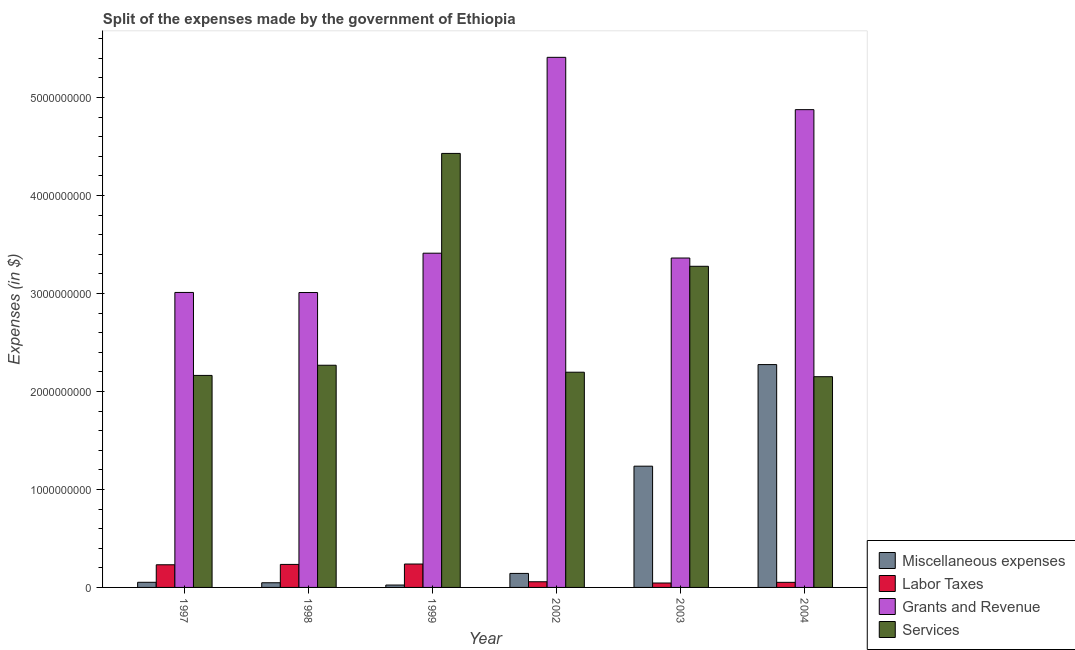How many different coloured bars are there?
Make the answer very short. 4. What is the amount spent on grants and revenue in 1999?
Provide a succinct answer. 3.41e+09. Across all years, what is the maximum amount spent on labor taxes?
Provide a succinct answer. 2.39e+08. Across all years, what is the minimum amount spent on labor taxes?
Keep it short and to the point. 4.51e+07. In which year was the amount spent on labor taxes maximum?
Ensure brevity in your answer.  1999. In which year was the amount spent on miscellaneous expenses minimum?
Offer a terse response. 1999. What is the total amount spent on miscellaneous expenses in the graph?
Ensure brevity in your answer.  3.78e+09. What is the difference between the amount spent on miscellaneous expenses in 1998 and that in 1999?
Make the answer very short. 2.33e+07. What is the difference between the amount spent on grants and revenue in 1997 and the amount spent on miscellaneous expenses in 1998?
Keep it short and to the point. 8.00e+05. What is the average amount spent on services per year?
Provide a short and direct response. 2.75e+09. In how many years, is the amount spent on labor taxes greater than 5200000000 $?
Your answer should be very brief. 0. What is the ratio of the amount spent on labor taxes in 2003 to that in 2004?
Provide a short and direct response. 0.87. Is the difference between the amount spent on grants and revenue in 2002 and 2003 greater than the difference between the amount spent on services in 2002 and 2003?
Your answer should be compact. No. What is the difference between the highest and the second highest amount spent on services?
Ensure brevity in your answer.  1.15e+09. What is the difference between the highest and the lowest amount spent on labor taxes?
Give a very brief answer. 1.94e+08. In how many years, is the amount spent on grants and revenue greater than the average amount spent on grants and revenue taken over all years?
Offer a very short reply. 2. Is it the case that in every year, the sum of the amount spent on miscellaneous expenses and amount spent on labor taxes is greater than the sum of amount spent on grants and revenue and amount spent on services?
Your response must be concise. No. What does the 1st bar from the left in 1998 represents?
Your response must be concise. Miscellaneous expenses. What does the 4th bar from the right in 2002 represents?
Offer a terse response. Miscellaneous expenses. Are all the bars in the graph horizontal?
Your response must be concise. No. How many years are there in the graph?
Provide a short and direct response. 6. Where does the legend appear in the graph?
Your answer should be very brief. Bottom right. How many legend labels are there?
Your answer should be compact. 4. How are the legend labels stacked?
Your response must be concise. Vertical. What is the title of the graph?
Offer a very short reply. Split of the expenses made by the government of Ethiopia. Does "Social equity" appear as one of the legend labels in the graph?
Offer a very short reply. No. What is the label or title of the Y-axis?
Provide a succinct answer. Expenses (in $). What is the Expenses (in $) in Miscellaneous expenses in 1997?
Offer a very short reply. 5.25e+07. What is the Expenses (in $) in Labor Taxes in 1997?
Provide a succinct answer. 2.31e+08. What is the Expenses (in $) in Grants and Revenue in 1997?
Ensure brevity in your answer.  3.01e+09. What is the Expenses (in $) in Services in 1997?
Provide a short and direct response. 2.16e+09. What is the Expenses (in $) in Miscellaneous expenses in 1998?
Your answer should be compact. 4.77e+07. What is the Expenses (in $) in Labor Taxes in 1998?
Your answer should be very brief. 2.35e+08. What is the Expenses (in $) of Grants and Revenue in 1998?
Offer a very short reply. 3.01e+09. What is the Expenses (in $) in Services in 1998?
Your answer should be very brief. 2.27e+09. What is the Expenses (in $) of Miscellaneous expenses in 1999?
Give a very brief answer. 2.44e+07. What is the Expenses (in $) in Labor Taxes in 1999?
Provide a succinct answer. 2.39e+08. What is the Expenses (in $) of Grants and Revenue in 1999?
Provide a short and direct response. 3.41e+09. What is the Expenses (in $) of Services in 1999?
Your answer should be compact. 4.43e+09. What is the Expenses (in $) in Miscellaneous expenses in 2002?
Offer a terse response. 1.43e+08. What is the Expenses (in $) of Labor Taxes in 2002?
Your response must be concise. 5.79e+07. What is the Expenses (in $) of Grants and Revenue in 2002?
Your answer should be very brief. 5.41e+09. What is the Expenses (in $) of Services in 2002?
Provide a short and direct response. 2.20e+09. What is the Expenses (in $) of Miscellaneous expenses in 2003?
Offer a very short reply. 1.24e+09. What is the Expenses (in $) of Labor Taxes in 2003?
Offer a very short reply. 4.51e+07. What is the Expenses (in $) of Grants and Revenue in 2003?
Keep it short and to the point. 3.36e+09. What is the Expenses (in $) in Services in 2003?
Provide a short and direct response. 3.28e+09. What is the Expenses (in $) in Miscellaneous expenses in 2004?
Offer a terse response. 2.27e+09. What is the Expenses (in $) of Labor Taxes in 2004?
Your response must be concise. 5.20e+07. What is the Expenses (in $) in Grants and Revenue in 2004?
Provide a succinct answer. 4.88e+09. What is the Expenses (in $) of Services in 2004?
Your answer should be compact. 2.15e+09. Across all years, what is the maximum Expenses (in $) of Miscellaneous expenses?
Your answer should be compact. 2.27e+09. Across all years, what is the maximum Expenses (in $) of Labor Taxes?
Ensure brevity in your answer.  2.39e+08. Across all years, what is the maximum Expenses (in $) in Grants and Revenue?
Your answer should be very brief. 5.41e+09. Across all years, what is the maximum Expenses (in $) of Services?
Ensure brevity in your answer.  4.43e+09. Across all years, what is the minimum Expenses (in $) of Miscellaneous expenses?
Provide a succinct answer. 2.44e+07. Across all years, what is the minimum Expenses (in $) of Labor Taxes?
Your response must be concise. 4.51e+07. Across all years, what is the minimum Expenses (in $) in Grants and Revenue?
Provide a succinct answer. 3.01e+09. Across all years, what is the minimum Expenses (in $) of Services?
Give a very brief answer. 2.15e+09. What is the total Expenses (in $) of Miscellaneous expenses in the graph?
Your answer should be very brief. 3.78e+09. What is the total Expenses (in $) of Labor Taxes in the graph?
Your answer should be very brief. 8.60e+08. What is the total Expenses (in $) of Grants and Revenue in the graph?
Make the answer very short. 2.31e+1. What is the total Expenses (in $) in Services in the graph?
Give a very brief answer. 1.65e+1. What is the difference between the Expenses (in $) of Miscellaneous expenses in 1997 and that in 1998?
Offer a terse response. 4.80e+06. What is the difference between the Expenses (in $) of Labor Taxes in 1997 and that in 1998?
Provide a succinct answer. -3.60e+06. What is the difference between the Expenses (in $) in Services in 1997 and that in 1998?
Provide a succinct answer. -1.04e+08. What is the difference between the Expenses (in $) in Miscellaneous expenses in 1997 and that in 1999?
Make the answer very short. 2.81e+07. What is the difference between the Expenses (in $) of Labor Taxes in 1997 and that in 1999?
Provide a short and direct response. -7.60e+06. What is the difference between the Expenses (in $) in Grants and Revenue in 1997 and that in 1999?
Your answer should be compact. -4.01e+08. What is the difference between the Expenses (in $) of Services in 1997 and that in 1999?
Your answer should be very brief. -2.27e+09. What is the difference between the Expenses (in $) of Miscellaneous expenses in 1997 and that in 2002?
Provide a succinct answer. -9.05e+07. What is the difference between the Expenses (in $) of Labor Taxes in 1997 and that in 2002?
Provide a short and direct response. 1.73e+08. What is the difference between the Expenses (in $) of Grants and Revenue in 1997 and that in 2002?
Provide a succinct answer. -2.40e+09. What is the difference between the Expenses (in $) of Services in 1997 and that in 2002?
Your answer should be compact. -3.27e+07. What is the difference between the Expenses (in $) in Miscellaneous expenses in 1997 and that in 2003?
Your response must be concise. -1.18e+09. What is the difference between the Expenses (in $) of Labor Taxes in 1997 and that in 2003?
Give a very brief answer. 1.86e+08. What is the difference between the Expenses (in $) in Grants and Revenue in 1997 and that in 2003?
Offer a very short reply. -3.51e+08. What is the difference between the Expenses (in $) in Services in 1997 and that in 2003?
Keep it short and to the point. -1.11e+09. What is the difference between the Expenses (in $) in Miscellaneous expenses in 1997 and that in 2004?
Ensure brevity in your answer.  -2.22e+09. What is the difference between the Expenses (in $) of Labor Taxes in 1997 and that in 2004?
Offer a very short reply. 1.79e+08. What is the difference between the Expenses (in $) in Grants and Revenue in 1997 and that in 2004?
Provide a short and direct response. -1.87e+09. What is the difference between the Expenses (in $) in Services in 1997 and that in 2004?
Provide a succinct answer. 1.30e+07. What is the difference between the Expenses (in $) in Miscellaneous expenses in 1998 and that in 1999?
Offer a very short reply. 2.33e+07. What is the difference between the Expenses (in $) in Labor Taxes in 1998 and that in 1999?
Your response must be concise. -4.00e+06. What is the difference between the Expenses (in $) of Grants and Revenue in 1998 and that in 1999?
Give a very brief answer. -4.01e+08. What is the difference between the Expenses (in $) in Services in 1998 and that in 1999?
Provide a succinct answer. -2.16e+09. What is the difference between the Expenses (in $) in Miscellaneous expenses in 1998 and that in 2002?
Offer a terse response. -9.53e+07. What is the difference between the Expenses (in $) in Labor Taxes in 1998 and that in 2002?
Your answer should be very brief. 1.77e+08. What is the difference between the Expenses (in $) of Grants and Revenue in 1998 and that in 2002?
Offer a very short reply. -2.40e+09. What is the difference between the Expenses (in $) of Services in 1998 and that in 2002?
Offer a very short reply. 7.11e+07. What is the difference between the Expenses (in $) of Miscellaneous expenses in 1998 and that in 2003?
Give a very brief answer. -1.19e+09. What is the difference between the Expenses (in $) in Labor Taxes in 1998 and that in 2003?
Ensure brevity in your answer.  1.90e+08. What is the difference between the Expenses (in $) in Grants and Revenue in 1998 and that in 2003?
Make the answer very short. -3.52e+08. What is the difference between the Expenses (in $) of Services in 1998 and that in 2003?
Ensure brevity in your answer.  -1.01e+09. What is the difference between the Expenses (in $) in Miscellaneous expenses in 1998 and that in 2004?
Offer a very short reply. -2.23e+09. What is the difference between the Expenses (in $) in Labor Taxes in 1998 and that in 2004?
Provide a succinct answer. 1.83e+08. What is the difference between the Expenses (in $) in Grants and Revenue in 1998 and that in 2004?
Give a very brief answer. -1.87e+09. What is the difference between the Expenses (in $) of Services in 1998 and that in 2004?
Keep it short and to the point. 1.17e+08. What is the difference between the Expenses (in $) in Miscellaneous expenses in 1999 and that in 2002?
Your answer should be compact. -1.19e+08. What is the difference between the Expenses (in $) of Labor Taxes in 1999 and that in 2002?
Make the answer very short. 1.81e+08. What is the difference between the Expenses (in $) of Grants and Revenue in 1999 and that in 2002?
Your answer should be very brief. -2.00e+09. What is the difference between the Expenses (in $) in Services in 1999 and that in 2002?
Your answer should be very brief. 2.23e+09. What is the difference between the Expenses (in $) in Miscellaneous expenses in 1999 and that in 2003?
Keep it short and to the point. -1.21e+09. What is the difference between the Expenses (in $) in Labor Taxes in 1999 and that in 2003?
Keep it short and to the point. 1.94e+08. What is the difference between the Expenses (in $) in Grants and Revenue in 1999 and that in 2003?
Your response must be concise. 4.93e+07. What is the difference between the Expenses (in $) in Services in 1999 and that in 2003?
Make the answer very short. 1.15e+09. What is the difference between the Expenses (in $) in Miscellaneous expenses in 1999 and that in 2004?
Provide a short and direct response. -2.25e+09. What is the difference between the Expenses (in $) of Labor Taxes in 1999 and that in 2004?
Your answer should be compact. 1.87e+08. What is the difference between the Expenses (in $) in Grants and Revenue in 1999 and that in 2004?
Your answer should be compact. -1.46e+09. What is the difference between the Expenses (in $) in Services in 1999 and that in 2004?
Make the answer very short. 2.28e+09. What is the difference between the Expenses (in $) of Miscellaneous expenses in 2002 and that in 2003?
Your response must be concise. -1.09e+09. What is the difference between the Expenses (in $) in Labor Taxes in 2002 and that in 2003?
Give a very brief answer. 1.28e+07. What is the difference between the Expenses (in $) of Grants and Revenue in 2002 and that in 2003?
Offer a terse response. 2.05e+09. What is the difference between the Expenses (in $) in Services in 2002 and that in 2003?
Give a very brief answer. -1.08e+09. What is the difference between the Expenses (in $) of Miscellaneous expenses in 2002 and that in 2004?
Your response must be concise. -2.13e+09. What is the difference between the Expenses (in $) in Labor Taxes in 2002 and that in 2004?
Provide a short and direct response. 5.90e+06. What is the difference between the Expenses (in $) of Grants and Revenue in 2002 and that in 2004?
Your response must be concise. 5.34e+08. What is the difference between the Expenses (in $) in Services in 2002 and that in 2004?
Provide a short and direct response. 4.57e+07. What is the difference between the Expenses (in $) of Miscellaneous expenses in 2003 and that in 2004?
Offer a very short reply. -1.04e+09. What is the difference between the Expenses (in $) in Labor Taxes in 2003 and that in 2004?
Your answer should be very brief. -6.90e+06. What is the difference between the Expenses (in $) in Grants and Revenue in 2003 and that in 2004?
Your answer should be very brief. -1.51e+09. What is the difference between the Expenses (in $) of Services in 2003 and that in 2004?
Ensure brevity in your answer.  1.13e+09. What is the difference between the Expenses (in $) of Miscellaneous expenses in 1997 and the Expenses (in $) of Labor Taxes in 1998?
Ensure brevity in your answer.  -1.82e+08. What is the difference between the Expenses (in $) in Miscellaneous expenses in 1997 and the Expenses (in $) in Grants and Revenue in 1998?
Provide a short and direct response. -2.96e+09. What is the difference between the Expenses (in $) of Miscellaneous expenses in 1997 and the Expenses (in $) of Services in 1998?
Ensure brevity in your answer.  -2.22e+09. What is the difference between the Expenses (in $) in Labor Taxes in 1997 and the Expenses (in $) in Grants and Revenue in 1998?
Provide a succinct answer. -2.78e+09. What is the difference between the Expenses (in $) in Labor Taxes in 1997 and the Expenses (in $) in Services in 1998?
Keep it short and to the point. -2.04e+09. What is the difference between the Expenses (in $) of Grants and Revenue in 1997 and the Expenses (in $) of Services in 1998?
Your answer should be compact. 7.43e+08. What is the difference between the Expenses (in $) of Miscellaneous expenses in 1997 and the Expenses (in $) of Labor Taxes in 1999?
Your answer should be very brief. -1.86e+08. What is the difference between the Expenses (in $) of Miscellaneous expenses in 1997 and the Expenses (in $) of Grants and Revenue in 1999?
Offer a very short reply. -3.36e+09. What is the difference between the Expenses (in $) in Miscellaneous expenses in 1997 and the Expenses (in $) in Services in 1999?
Your answer should be compact. -4.38e+09. What is the difference between the Expenses (in $) of Labor Taxes in 1997 and the Expenses (in $) of Grants and Revenue in 1999?
Give a very brief answer. -3.18e+09. What is the difference between the Expenses (in $) in Labor Taxes in 1997 and the Expenses (in $) in Services in 1999?
Give a very brief answer. -4.20e+09. What is the difference between the Expenses (in $) in Grants and Revenue in 1997 and the Expenses (in $) in Services in 1999?
Your response must be concise. -1.42e+09. What is the difference between the Expenses (in $) in Miscellaneous expenses in 1997 and the Expenses (in $) in Labor Taxes in 2002?
Offer a terse response. -5.40e+06. What is the difference between the Expenses (in $) of Miscellaneous expenses in 1997 and the Expenses (in $) of Grants and Revenue in 2002?
Give a very brief answer. -5.36e+09. What is the difference between the Expenses (in $) in Miscellaneous expenses in 1997 and the Expenses (in $) in Services in 2002?
Give a very brief answer. -2.14e+09. What is the difference between the Expenses (in $) of Labor Taxes in 1997 and the Expenses (in $) of Grants and Revenue in 2002?
Your response must be concise. -5.18e+09. What is the difference between the Expenses (in $) in Labor Taxes in 1997 and the Expenses (in $) in Services in 2002?
Provide a succinct answer. -1.97e+09. What is the difference between the Expenses (in $) in Grants and Revenue in 1997 and the Expenses (in $) in Services in 2002?
Offer a very short reply. 8.14e+08. What is the difference between the Expenses (in $) in Miscellaneous expenses in 1997 and the Expenses (in $) in Labor Taxes in 2003?
Provide a short and direct response. 7.40e+06. What is the difference between the Expenses (in $) of Miscellaneous expenses in 1997 and the Expenses (in $) of Grants and Revenue in 2003?
Offer a terse response. -3.31e+09. What is the difference between the Expenses (in $) in Miscellaneous expenses in 1997 and the Expenses (in $) in Services in 2003?
Make the answer very short. -3.23e+09. What is the difference between the Expenses (in $) in Labor Taxes in 1997 and the Expenses (in $) in Grants and Revenue in 2003?
Provide a short and direct response. -3.13e+09. What is the difference between the Expenses (in $) of Labor Taxes in 1997 and the Expenses (in $) of Services in 2003?
Offer a terse response. -3.05e+09. What is the difference between the Expenses (in $) in Grants and Revenue in 1997 and the Expenses (in $) in Services in 2003?
Provide a succinct answer. -2.67e+08. What is the difference between the Expenses (in $) of Miscellaneous expenses in 1997 and the Expenses (in $) of Grants and Revenue in 2004?
Keep it short and to the point. -4.82e+09. What is the difference between the Expenses (in $) of Miscellaneous expenses in 1997 and the Expenses (in $) of Services in 2004?
Provide a succinct answer. -2.10e+09. What is the difference between the Expenses (in $) in Labor Taxes in 1997 and the Expenses (in $) in Grants and Revenue in 2004?
Keep it short and to the point. -4.65e+09. What is the difference between the Expenses (in $) in Labor Taxes in 1997 and the Expenses (in $) in Services in 2004?
Keep it short and to the point. -1.92e+09. What is the difference between the Expenses (in $) in Grants and Revenue in 1997 and the Expenses (in $) in Services in 2004?
Your answer should be very brief. 8.60e+08. What is the difference between the Expenses (in $) in Miscellaneous expenses in 1998 and the Expenses (in $) in Labor Taxes in 1999?
Your answer should be compact. -1.91e+08. What is the difference between the Expenses (in $) of Miscellaneous expenses in 1998 and the Expenses (in $) of Grants and Revenue in 1999?
Make the answer very short. -3.36e+09. What is the difference between the Expenses (in $) of Miscellaneous expenses in 1998 and the Expenses (in $) of Services in 1999?
Make the answer very short. -4.38e+09. What is the difference between the Expenses (in $) in Labor Taxes in 1998 and the Expenses (in $) in Grants and Revenue in 1999?
Give a very brief answer. -3.18e+09. What is the difference between the Expenses (in $) of Labor Taxes in 1998 and the Expenses (in $) of Services in 1999?
Your response must be concise. -4.19e+09. What is the difference between the Expenses (in $) in Grants and Revenue in 1998 and the Expenses (in $) in Services in 1999?
Offer a very short reply. -1.42e+09. What is the difference between the Expenses (in $) of Miscellaneous expenses in 1998 and the Expenses (in $) of Labor Taxes in 2002?
Give a very brief answer. -1.02e+07. What is the difference between the Expenses (in $) of Miscellaneous expenses in 1998 and the Expenses (in $) of Grants and Revenue in 2002?
Your answer should be very brief. -5.36e+09. What is the difference between the Expenses (in $) in Miscellaneous expenses in 1998 and the Expenses (in $) in Services in 2002?
Your answer should be very brief. -2.15e+09. What is the difference between the Expenses (in $) of Labor Taxes in 1998 and the Expenses (in $) of Grants and Revenue in 2002?
Your response must be concise. -5.18e+09. What is the difference between the Expenses (in $) in Labor Taxes in 1998 and the Expenses (in $) in Services in 2002?
Your response must be concise. -1.96e+09. What is the difference between the Expenses (in $) of Grants and Revenue in 1998 and the Expenses (in $) of Services in 2002?
Offer a very short reply. 8.13e+08. What is the difference between the Expenses (in $) in Miscellaneous expenses in 1998 and the Expenses (in $) in Labor Taxes in 2003?
Make the answer very short. 2.60e+06. What is the difference between the Expenses (in $) of Miscellaneous expenses in 1998 and the Expenses (in $) of Grants and Revenue in 2003?
Offer a very short reply. -3.31e+09. What is the difference between the Expenses (in $) in Miscellaneous expenses in 1998 and the Expenses (in $) in Services in 2003?
Keep it short and to the point. -3.23e+09. What is the difference between the Expenses (in $) of Labor Taxes in 1998 and the Expenses (in $) of Grants and Revenue in 2003?
Keep it short and to the point. -3.13e+09. What is the difference between the Expenses (in $) in Labor Taxes in 1998 and the Expenses (in $) in Services in 2003?
Give a very brief answer. -3.04e+09. What is the difference between the Expenses (in $) in Grants and Revenue in 1998 and the Expenses (in $) in Services in 2003?
Make the answer very short. -2.68e+08. What is the difference between the Expenses (in $) of Miscellaneous expenses in 1998 and the Expenses (in $) of Labor Taxes in 2004?
Provide a succinct answer. -4.30e+06. What is the difference between the Expenses (in $) in Miscellaneous expenses in 1998 and the Expenses (in $) in Grants and Revenue in 2004?
Your answer should be very brief. -4.83e+09. What is the difference between the Expenses (in $) of Miscellaneous expenses in 1998 and the Expenses (in $) of Services in 2004?
Offer a terse response. -2.10e+09. What is the difference between the Expenses (in $) of Labor Taxes in 1998 and the Expenses (in $) of Grants and Revenue in 2004?
Make the answer very short. -4.64e+09. What is the difference between the Expenses (in $) of Labor Taxes in 1998 and the Expenses (in $) of Services in 2004?
Your response must be concise. -1.92e+09. What is the difference between the Expenses (in $) of Grants and Revenue in 1998 and the Expenses (in $) of Services in 2004?
Provide a succinct answer. 8.59e+08. What is the difference between the Expenses (in $) of Miscellaneous expenses in 1999 and the Expenses (in $) of Labor Taxes in 2002?
Give a very brief answer. -3.35e+07. What is the difference between the Expenses (in $) in Miscellaneous expenses in 1999 and the Expenses (in $) in Grants and Revenue in 2002?
Offer a very short reply. -5.39e+09. What is the difference between the Expenses (in $) of Miscellaneous expenses in 1999 and the Expenses (in $) of Services in 2002?
Provide a succinct answer. -2.17e+09. What is the difference between the Expenses (in $) in Labor Taxes in 1999 and the Expenses (in $) in Grants and Revenue in 2002?
Provide a succinct answer. -5.17e+09. What is the difference between the Expenses (in $) in Labor Taxes in 1999 and the Expenses (in $) in Services in 2002?
Offer a terse response. -1.96e+09. What is the difference between the Expenses (in $) in Grants and Revenue in 1999 and the Expenses (in $) in Services in 2002?
Offer a very short reply. 1.21e+09. What is the difference between the Expenses (in $) of Miscellaneous expenses in 1999 and the Expenses (in $) of Labor Taxes in 2003?
Give a very brief answer. -2.07e+07. What is the difference between the Expenses (in $) of Miscellaneous expenses in 1999 and the Expenses (in $) of Grants and Revenue in 2003?
Provide a succinct answer. -3.34e+09. What is the difference between the Expenses (in $) in Miscellaneous expenses in 1999 and the Expenses (in $) in Services in 2003?
Make the answer very short. -3.25e+09. What is the difference between the Expenses (in $) in Labor Taxes in 1999 and the Expenses (in $) in Grants and Revenue in 2003?
Your answer should be very brief. -3.12e+09. What is the difference between the Expenses (in $) of Labor Taxes in 1999 and the Expenses (in $) of Services in 2003?
Give a very brief answer. -3.04e+09. What is the difference between the Expenses (in $) of Grants and Revenue in 1999 and the Expenses (in $) of Services in 2003?
Your response must be concise. 1.34e+08. What is the difference between the Expenses (in $) in Miscellaneous expenses in 1999 and the Expenses (in $) in Labor Taxes in 2004?
Offer a very short reply. -2.76e+07. What is the difference between the Expenses (in $) of Miscellaneous expenses in 1999 and the Expenses (in $) of Grants and Revenue in 2004?
Your response must be concise. -4.85e+09. What is the difference between the Expenses (in $) of Miscellaneous expenses in 1999 and the Expenses (in $) of Services in 2004?
Offer a very short reply. -2.13e+09. What is the difference between the Expenses (in $) in Labor Taxes in 1999 and the Expenses (in $) in Grants and Revenue in 2004?
Ensure brevity in your answer.  -4.64e+09. What is the difference between the Expenses (in $) of Labor Taxes in 1999 and the Expenses (in $) of Services in 2004?
Your answer should be very brief. -1.91e+09. What is the difference between the Expenses (in $) of Grants and Revenue in 1999 and the Expenses (in $) of Services in 2004?
Your response must be concise. 1.26e+09. What is the difference between the Expenses (in $) in Miscellaneous expenses in 2002 and the Expenses (in $) in Labor Taxes in 2003?
Keep it short and to the point. 9.79e+07. What is the difference between the Expenses (in $) in Miscellaneous expenses in 2002 and the Expenses (in $) in Grants and Revenue in 2003?
Make the answer very short. -3.22e+09. What is the difference between the Expenses (in $) in Miscellaneous expenses in 2002 and the Expenses (in $) in Services in 2003?
Offer a very short reply. -3.13e+09. What is the difference between the Expenses (in $) in Labor Taxes in 2002 and the Expenses (in $) in Grants and Revenue in 2003?
Make the answer very short. -3.30e+09. What is the difference between the Expenses (in $) of Labor Taxes in 2002 and the Expenses (in $) of Services in 2003?
Your answer should be very brief. -3.22e+09. What is the difference between the Expenses (in $) of Grants and Revenue in 2002 and the Expenses (in $) of Services in 2003?
Keep it short and to the point. 2.13e+09. What is the difference between the Expenses (in $) in Miscellaneous expenses in 2002 and the Expenses (in $) in Labor Taxes in 2004?
Offer a terse response. 9.10e+07. What is the difference between the Expenses (in $) of Miscellaneous expenses in 2002 and the Expenses (in $) of Grants and Revenue in 2004?
Ensure brevity in your answer.  -4.73e+09. What is the difference between the Expenses (in $) in Miscellaneous expenses in 2002 and the Expenses (in $) in Services in 2004?
Provide a succinct answer. -2.01e+09. What is the difference between the Expenses (in $) in Labor Taxes in 2002 and the Expenses (in $) in Grants and Revenue in 2004?
Provide a succinct answer. -4.82e+09. What is the difference between the Expenses (in $) of Labor Taxes in 2002 and the Expenses (in $) of Services in 2004?
Make the answer very short. -2.09e+09. What is the difference between the Expenses (in $) of Grants and Revenue in 2002 and the Expenses (in $) of Services in 2004?
Offer a terse response. 3.26e+09. What is the difference between the Expenses (in $) of Miscellaneous expenses in 2003 and the Expenses (in $) of Labor Taxes in 2004?
Make the answer very short. 1.19e+09. What is the difference between the Expenses (in $) of Miscellaneous expenses in 2003 and the Expenses (in $) of Grants and Revenue in 2004?
Your response must be concise. -3.64e+09. What is the difference between the Expenses (in $) of Miscellaneous expenses in 2003 and the Expenses (in $) of Services in 2004?
Ensure brevity in your answer.  -9.13e+08. What is the difference between the Expenses (in $) of Labor Taxes in 2003 and the Expenses (in $) of Grants and Revenue in 2004?
Offer a very short reply. -4.83e+09. What is the difference between the Expenses (in $) of Labor Taxes in 2003 and the Expenses (in $) of Services in 2004?
Your response must be concise. -2.11e+09. What is the difference between the Expenses (in $) in Grants and Revenue in 2003 and the Expenses (in $) in Services in 2004?
Your answer should be compact. 1.21e+09. What is the average Expenses (in $) of Miscellaneous expenses per year?
Give a very brief answer. 6.30e+08. What is the average Expenses (in $) in Labor Taxes per year?
Your response must be concise. 1.43e+08. What is the average Expenses (in $) in Grants and Revenue per year?
Keep it short and to the point. 3.85e+09. What is the average Expenses (in $) in Services per year?
Give a very brief answer. 2.75e+09. In the year 1997, what is the difference between the Expenses (in $) of Miscellaneous expenses and Expenses (in $) of Labor Taxes?
Provide a succinct answer. -1.79e+08. In the year 1997, what is the difference between the Expenses (in $) of Miscellaneous expenses and Expenses (in $) of Grants and Revenue?
Keep it short and to the point. -2.96e+09. In the year 1997, what is the difference between the Expenses (in $) of Miscellaneous expenses and Expenses (in $) of Services?
Offer a terse response. -2.11e+09. In the year 1997, what is the difference between the Expenses (in $) in Labor Taxes and Expenses (in $) in Grants and Revenue?
Your answer should be compact. -2.78e+09. In the year 1997, what is the difference between the Expenses (in $) in Labor Taxes and Expenses (in $) in Services?
Ensure brevity in your answer.  -1.93e+09. In the year 1997, what is the difference between the Expenses (in $) in Grants and Revenue and Expenses (in $) in Services?
Keep it short and to the point. 8.47e+08. In the year 1998, what is the difference between the Expenses (in $) in Miscellaneous expenses and Expenses (in $) in Labor Taxes?
Ensure brevity in your answer.  -1.87e+08. In the year 1998, what is the difference between the Expenses (in $) in Miscellaneous expenses and Expenses (in $) in Grants and Revenue?
Give a very brief answer. -2.96e+09. In the year 1998, what is the difference between the Expenses (in $) of Miscellaneous expenses and Expenses (in $) of Services?
Keep it short and to the point. -2.22e+09. In the year 1998, what is the difference between the Expenses (in $) of Labor Taxes and Expenses (in $) of Grants and Revenue?
Your answer should be compact. -2.78e+09. In the year 1998, what is the difference between the Expenses (in $) in Labor Taxes and Expenses (in $) in Services?
Make the answer very short. -2.03e+09. In the year 1998, what is the difference between the Expenses (in $) of Grants and Revenue and Expenses (in $) of Services?
Keep it short and to the point. 7.42e+08. In the year 1999, what is the difference between the Expenses (in $) of Miscellaneous expenses and Expenses (in $) of Labor Taxes?
Make the answer very short. -2.14e+08. In the year 1999, what is the difference between the Expenses (in $) in Miscellaneous expenses and Expenses (in $) in Grants and Revenue?
Your answer should be very brief. -3.39e+09. In the year 1999, what is the difference between the Expenses (in $) in Miscellaneous expenses and Expenses (in $) in Services?
Your answer should be very brief. -4.41e+09. In the year 1999, what is the difference between the Expenses (in $) of Labor Taxes and Expenses (in $) of Grants and Revenue?
Ensure brevity in your answer.  -3.17e+09. In the year 1999, what is the difference between the Expenses (in $) of Labor Taxes and Expenses (in $) of Services?
Provide a short and direct response. -4.19e+09. In the year 1999, what is the difference between the Expenses (in $) in Grants and Revenue and Expenses (in $) in Services?
Make the answer very short. -1.02e+09. In the year 2002, what is the difference between the Expenses (in $) in Miscellaneous expenses and Expenses (in $) in Labor Taxes?
Offer a very short reply. 8.51e+07. In the year 2002, what is the difference between the Expenses (in $) in Miscellaneous expenses and Expenses (in $) in Grants and Revenue?
Offer a very short reply. -5.27e+09. In the year 2002, what is the difference between the Expenses (in $) of Miscellaneous expenses and Expenses (in $) of Services?
Offer a very short reply. -2.05e+09. In the year 2002, what is the difference between the Expenses (in $) of Labor Taxes and Expenses (in $) of Grants and Revenue?
Make the answer very short. -5.35e+09. In the year 2002, what is the difference between the Expenses (in $) in Labor Taxes and Expenses (in $) in Services?
Make the answer very short. -2.14e+09. In the year 2002, what is the difference between the Expenses (in $) in Grants and Revenue and Expenses (in $) in Services?
Make the answer very short. 3.21e+09. In the year 2003, what is the difference between the Expenses (in $) of Miscellaneous expenses and Expenses (in $) of Labor Taxes?
Keep it short and to the point. 1.19e+09. In the year 2003, what is the difference between the Expenses (in $) in Miscellaneous expenses and Expenses (in $) in Grants and Revenue?
Your answer should be very brief. -2.12e+09. In the year 2003, what is the difference between the Expenses (in $) of Miscellaneous expenses and Expenses (in $) of Services?
Offer a terse response. -2.04e+09. In the year 2003, what is the difference between the Expenses (in $) of Labor Taxes and Expenses (in $) of Grants and Revenue?
Ensure brevity in your answer.  -3.32e+09. In the year 2003, what is the difference between the Expenses (in $) in Labor Taxes and Expenses (in $) in Services?
Provide a succinct answer. -3.23e+09. In the year 2003, what is the difference between the Expenses (in $) in Grants and Revenue and Expenses (in $) in Services?
Your answer should be compact. 8.44e+07. In the year 2004, what is the difference between the Expenses (in $) in Miscellaneous expenses and Expenses (in $) in Labor Taxes?
Offer a terse response. 2.22e+09. In the year 2004, what is the difference between the Expenses (in $) of Miscellaneous expenses and Expenses (in $) of Grants and Revenue?
Provide a short and direct response. -2.60e+09. In the year 2004, what is the difference between the Expenses (in $) in Miscellaneous expenses and Expenses (in $) in Services?
Make the answer very short. 1.24e+08. In the year 2004, what is the difference between the Expenses (in $) in Labor Taxes and Expenses (in $) in Grants and Revenue?
Keep it short and to the point. -4.82e+09. In the year 2004, what is the difference between the Expenses (in $) in Labor Taxes and Expenses (in $) in Services?
Keep it short and to the point. -2.10e+09. In the year 2004, what is the difference between the Expenses (in $) in Grants and Revenue and Expenses (in $) in Services?
Keep it short and to the point. 2.73e+09. What is the ratio of the Expenses (in $) of Miscellaneous expenses in 1997 to that in 1998?
Keep it short and to the point. 1.1. What is the ratio of the Expenses (in $) in Labor Taxes in 1997 to that in 1998?
Offer a very short reply. 0.98. What is the ratio of the Expenses (in $) of Grants and Revenue in 1997 to that in 1998?
Give a very brief answer. 1. What is the ratio of the Expenses (in $) of Services in 1997 to that in 1998?
Offer a terse response. 0.95. What is the ratio of the Expenses (in $) in Miscellaneous expenses in 1997 to that in 1999?
Keep it short and to the point. 2.15. What is the ratio of the Expenses (in $) of Labor Taxes in 1997 to that in 1999?
Offer a terse response. 0.97. What is the ratio of the Expenses (in $) of Grants and Revenue in 1997 to that in 1999?
Offer a terse response. 0.88. What is the ratio of the Expenses (in $) of Services in 1997 to that in 1999?
Give a very brief answer. 0.49. What is the ratio of the Expenses (in $) of Miscellaneous expenses in 1997 to that in 2002?
Make the answer very short. 0.37. What is the ratio of the Expenses (in $) in Labor Taxes in 1997 to that in 2002?
Provide a succinct answer. 3.99. What is the ratio of the Expenses (in $) in Grants and Revenue in 1997 to that in 2002?
Make the answer very short. 0.56. What is the ratio of the Expenses (in $) in Services in 1997 to that in 2002?
Offer a terse response. 0.99. What is the ratio of the Expenses (in $) in Miscellaneous expenses in 1997 to that in 2003?
Make the answer very short. 0.04. What is the ratio of the Expenses (in $) in Labor Taxes in 1997 to that in 2003?
Offer a terse response. 5.13. What is the ratio of the Expenses (in $) in Grants and Revenue in 1997 to that in 2003?
Make the answer very short. 0.9. What is the ratio of the Expenses (in $) in Services in 1997 to that in 2003?
Offer a terse response. 0.66. What is the ratio of the Expenses (in $) in Miscellaneous expenses in 1997 to that in 2004?
Your answer should be compact. 0.02. What is the ratio of the Expenses (in $) of Labor Taxes in 1997 to that in 2004?
Give a very brief answer. 4.45. What is the ratio of the Expenses (in $) of Grants and Revenue in 1997 to that in 2004?
Make the answer very short. 0.62. What is the ratio of the Expenses (in $) of Services in 1997 to that in 2004?
Offer a very short reply. 1.01. What is the ratio of the Expenses (in $) of Miscellaneous expenses in 1998 to that in 1999?
Give a very brief answer. 1.95. What is the ratio of the Expenses (in $) in Labor Taxes in 1998 to that in 1999?
Your answer should be compact. 0.98. What is the ratio of the Expenses (in $) in Grants and Revenue in 1998 to that in 1999?
Offer a very short reply. 0.88. What is the ratio of the Expenses (in $) of Services in 1998 to that in 1999?
Your answer should be very brief. 0.51. What is the ratio of the Expenses (in $) of Miscellaneous expenses in 1998 to that in 2002?
Give a very brief answer. 0.33. What is the ratio of the Expenses (in $) in Labor Taxes in 1998 to that in 2002?
Ensure brevity in your answer.  4.06. What is the ratio of the Expenses (in $) of Grants and Revenue in 1998 to that in 2002?
Offer a very short reply. 0.56. What is the ratio of the Expenses (in $) in Services in 1998 to that in 2002?
Keep it short and to the point. 1.03. What is the ratio of the Expenses (in $) in Miscellaneous expenses in 1998 to that in 2003?
Provide a succinct answer. 0.04. What is the ratio of the Expenses (in $) of Labor Taxes in 1998 to that in 2003?
Ensure brevity in your answer.  5.21. What is the ratio of the Expenses (in $) in Grants and Revenue in 1998 to that in 2003?
Provide a short and direct response. 0.9. What is the ratio of the Expenses (in $) of Services in 1998 to that in 2003?
Offer a terse response. 0.69. What is the ratio of the Expenses (in $) of Miscellaneous expenses in 1998 to that in 2004?
Your answer should be very brief. 0.02. What is the ratio of the Expenses (in $) of Labor Taxes in 1998 to that in 2004?
Provide a succinct answer. 4.52. What is the ratio of the Expenses (in $) of Grants and Revenue in 1998 to that in 2004?
Provide a succinct answer. 0.62. What is the ratio of the Expenses (in $) of Services in 1998 to that in 2004?
Give a very brief answer. 1.05. What is the ratio of the Expenses (in $) of Miscellaneous expenses in 1999 to that in 2002?
Give a very brief answer. 0.17. What is the ratio of the Expenses (in $) of Labor Taxes in 1999 to that in 2002?
Your answer should be compact. 4.12. What is the ratio of the Expenses (in $) of Grants and Revenue in 1999 to that in 2002?
Keep it short and to the point. 0.63. What is the ratio of the Expenses (in $) in Services in 1999 to that in 2002?
Ensure brevity in your answer.  2.02. What is the ratio of the Expenses (in $) of Miscellaneous expenses in 1999 to that in 2003?
Provide a succinct answer. 0.02. What is the ratio of the Expenses (in $) of Labor Taxes in 1999 to that in 2003?
Give a very brief answer. 5.29. What is the ratio of the Expenses (in $) in Grants and Revenue in 1999 to that in 2003?
Provide a short and direct response. 1.01. What is the ratio of the Expenses (in $) in Services in 1999 to that in 2003?
Your answer should be very brief. 1.35. What is the ratio of the Expenses (in $) of Miscellaneous expenses in 1999 to that in 2004?
Provide a short and direct response. 0.01. What is the ratio of the Expenses (in $) of Labor Taxes in 1999 to that in 2004?
Your answer should be compact. 4.59. What is the ratio of the Expenses (in $) of Grants and Revenue in 1999 to that in 2004?
Give a very brief answer. 0.7. What is the ratio of the Expenses (in $) in Services in 1999 to that in 2004?
Provide a short and direct response. 2.06. What is the ratio of the Expenses (in $) in Miscellaneous expenses in 2002 to that in 2003?
Your response must be concise. 0.12. What is the ratio of the Expenses (in $) of Labor Taxes in 2002 to that in 2003?
Keep it short and to the point. 1.28. What is the ratio of the Expenses (in $) in Grants and Revenue in 2002 to that in 2003?
Keep it short and to the point. 1.61. What is the ratio of the Expenses (in $) in Services in 2002 to that in 2003?
Offer a terse response. 0.67. What is the ratio of the Expenses (in $) in Miscellaneous expenses in 2002 to that in 2004?
Offer a terse response. 0.06. What is the ratio of the Expenses (in $) in Labor Taxes in 2002 to that in 2004?
Make the answer very short. 1.11. What is the ratio of the Expenses (in $) of Grants and Revenue in 2002 to that in 2004?
Your answer should be compact. 1.11. What is the ratio of the Expenses (in $) in Services in 2002 to that in 2004?
Your answer should be very brief. 1.02. What is the ratio of the Expenses (in $) in Miscellaneous expenses in 2003 to that in 2004?
Provide a short and direct response. 0.54. What is the ratio of the Expenses (in $) in Labor Taxes in 2003 to that in 2004?
Make the answer very short. 0.87. What is the ratio of the Expenses (in $) in Grants and Revenue in 2003 to that in 2004?
Offer a very short reply. 0.69. What is the ratio of the Expenses (in $) of Services in 2003 to that in 2004?
Give a very brief answer. 1.52. What is the difference between the highest and the second highest Expenses (in $) in Miscellaneous expenses?
Keep it short and to the point. 1.04e+09. What is the difference between the highest and the second highest Expenses (in $) in Grants and Revenue?
Give a very brief answer. 5.34e+08. What is the difference between the highest and the second highest Expenses (in $) in Services?
Provide a short and direct response. 1.15e+09. What is the difference between the highest and the lowest Expenses (in $) of Miscellaneous expenses?
Offer a terse response. 2.25e+09. What is the difference between the highest and the lowest Expenses (in $) of Labor Taxes?
Make the answer very short. 1.94e+08. What is the difference between the highest and the lowest Expenses (in $) in Grants and Revenue?
Your answer should be very brief. 2.40e+09. What is the difference between the highest and the lowest Expenses (in $) in Services?
Offer a very short reply. 2.28e+09. 